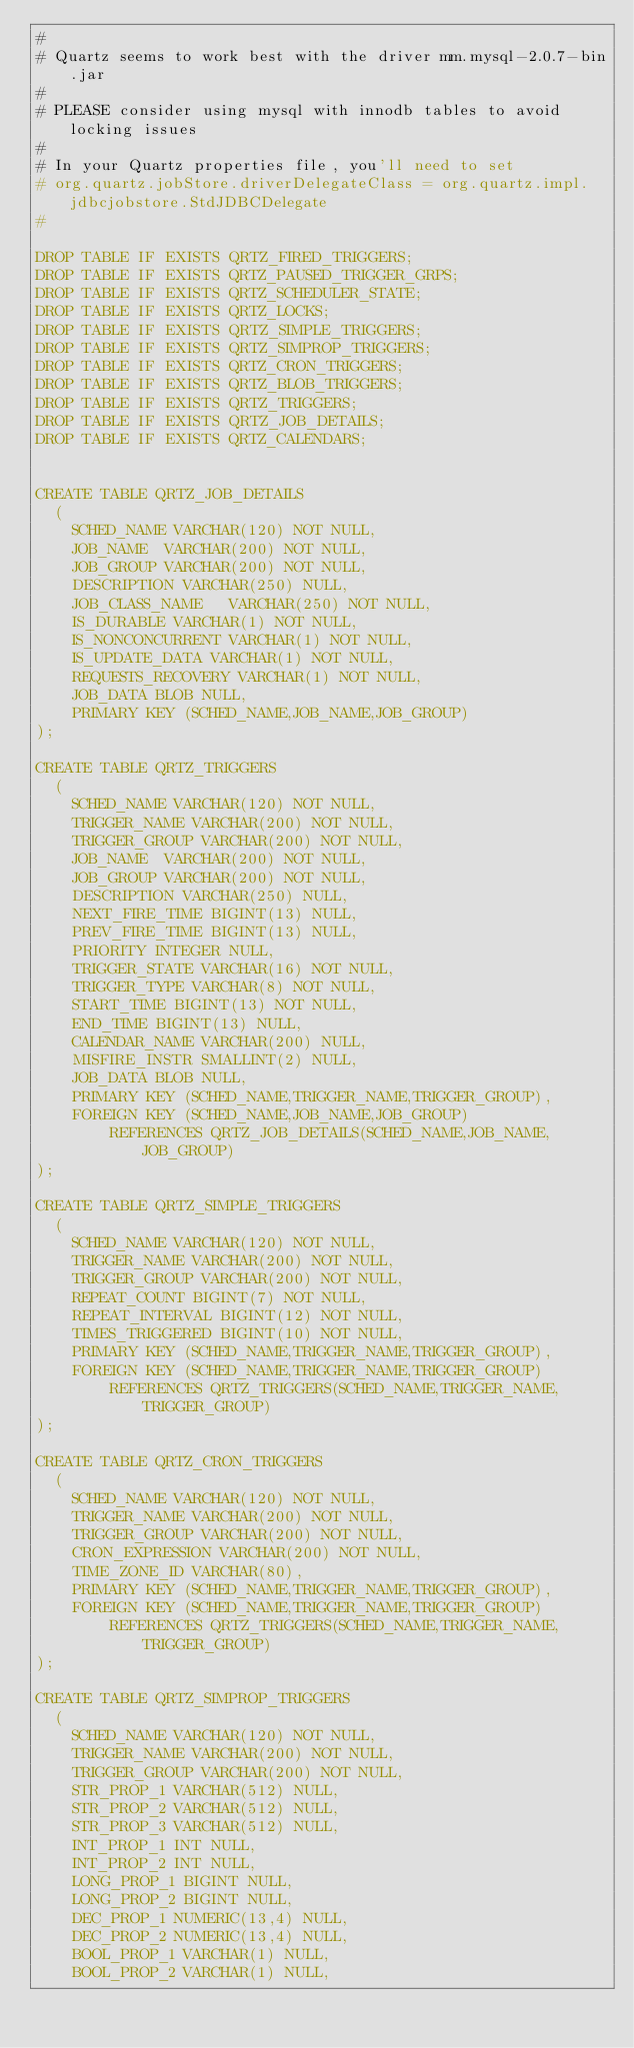<code> <loc_0><loc_0><loc_500><loc_500><_SQL_>#
# Quartz seems to work best with the driver mm.mysql-2.0.7-bin.jar
#
# PLEASE consider using mysql with innodb tables to avoid locking issues
#
# In your Quartz properties file, you'll need to set
# org.quartz.jobStore.driverDelegateClass = org.quartz.impl.jdbcjobstore.StdJDBCDelegate
#

DROP TABLE IF EXISTS QRTZ_FIRED_TRIGGERS;
DROP TABLE IF EXISTS QRTZ_PAUSED_TRIGGER_GRPS;
DROP TABLE IF EXISTS QRTZ_SCHEDULER_STATE;
DROP TABLE IF EXISTS QRTZ_LOCKS;
DROP TABLE IF EXISTS QRTZ_SIMPLE_TRIGGERS;
DROP TABLE IF EXISTS QRTZ_SIMPROP_TRIGGERS;
DROP TABLE IF EXISTS QRTZ_CRON_TRIGGERS;
DROP TABLE IF EXISTS QRTZ_BLOB_TRIGGERS;
DROP TABLE IF EXISTS QRTZ_TRIGGERS;
DROP TABLE IF EXISTS QRTZ_JOB_DETAILS;
DROP TABLE IF EXISTS QRTZ_CALENDARS;


CREATE TABLE QRTZ_JOB_DETAILS
  (
    SCHED_NAME VARCHAR(120) NOT NULL,
    JOB_NAME  VARCHAR(200) NOT NULL,
    JOB_GROUP VARCHAR(200) NOT NULL,
    DESCRIPTION VARCHAR(250) NULL,
    JOB_CLASS_NAME   VARCHAR(250) NOT NULL,
    IS_DURABLE VARCHAR(1) NOT NULL,
    IS_NONCONCURRENT VARCHAR(1) NOT NULL,
    IS_UPDATE_DATA VARCHAR(1) NOT NULL,
    REQUESTS_RECOVERY VARCHAR(1) NOT NULL,
    JOB_DATA BLOB NULL,
    PRIMARY KEY (SCHED_NAME,JOB_NAME,JOB_GROUP)
);

CREATE TABLE QRTZ_TRIGGERS
  (
    SCHED_NAME VARCHAR(120) NOT NULL,
    TRIGGER_NAME VARCHAR(200) NOT NULL,
    TRIGGER_GROUP VARCHAR(200) NOT NULL,
    JOB_NAME  VARCHAR(200) NOT NULL,
    JOB_GROUP VARCHAR(200) NOT NULL,
    DESCRIPTION VARCHAR(250) NULL,
    NEXT_FIRE_TIME BIGINT(13) NULL,
    PREV_FIRE_TIME BIGINT(13) NULL,
    PRIORITY INTEGER NULL,
    TRIGGER_STATE VARCHAR(16) NOT NULL,
    TRIGGER_TYPE VARCHAR(8) NOT NULL,
    START_TIME BIGINT(13) NOT NULL,
    END_TIME BIGINT(13) NULL,
    CALENDAR_NAME VARCHAR(200) NULL,
    MISFIRE_INSTR SMALLINT(2) NULL,
    JOB_DATA BLOB NULL,
    PRIMARY KEY (SCHED_NAME,TRIGGER_NAME,TRIGGER_GROUP),
    FOREIGN KEY (SCHED_NAME,JOB_NAME,JOB_GROUP)
        REFERENCES QRTZ_JOB_DETAILS(SCHED_NAME,JOB_NAME,JOB_GROUP)
);

CREATE TABLE QRTZ_SIMPLE_TRIGGERS
  (
    SCHED_NAME VARCHAR(120) NOT NULL,
    TRIGGER_NAME VARCHAR(200) NOT NULL,
    TRIGGER_GROUP VARCHAR(200) NOT NULL,
    REPEAT_COUNT BIGINT(7) NOT NULL,
    REPEAT_INTERVAL BIGINT(12) NOT NULL,
    TIMES_TRIGGERED BIGINT(10) NOT NULL,
    PRIMARY KEY (SCHED_NAME,TRIGGER_NAME,TRIGGER_GROUP),
    FOREIGN KEY (SCHED_NAME,TRIGGER_NAME,TRIGGER_GROUP)
        REFERENCES QRTZ_TRIGGERS(SCHED_NAME,TRIGGER_NAME,TRIGGER_GROUP)
);

CREATE TABLE QRTZ_CRON_TRIGGERS
  (
    SCHED_NAME VARCHAR(120) NOT NULL,
    TRIGGER_NAME VARCHAR(200) NOT NULL,
    TRIGGER_GROUP VARCHAR(200) NOT NULL,
    CRON_EXPRESSION VARCHAR(200) NOT NULL,
    TIME_ZONE_ID VARCHAR(80),
    PRIMARY KEY (SCHED_NAME,TRIGGER_NAME,TRIGGER_GROUP),
    FOREIGN KEY (SCHED_NAME,TRIGGER_NAME,TRIGGER_GROUP)
        REFERENCES QRTZ_TRIGGERS(SCHED_NAME,TRIGGER_NAME,TRIGGER_GROUP)
);

CREATE TABLE QRTZ_SIMPROP_TRIGGERS
  (
    SCHED_NAME VARCHAR(120) NOT NULL,
    TRIGGER_NAME VARCHAR(200) NOT NULL,
    TRIGGER_GROUP VARCHAR(200) NOT NULL,
    STR_PROP_1 VARCHAR(512) NULL,
    STR_PROP_2 VARCHAR(512) NULL,
    STR_PROP_3 VARCHAR(512) NULL,
    INT_PROP_1 INT NULL,
    INT_PROP_2 INT NULL,
    LONG_PROP_1 BIGINT NULL,
    LONG_PROP_2 BIGINT NULL,
    DEC_PROP_1 NUMERIC(13,4) NULL,
    DEC_PROP_2 NUMERIC(13,4) NULL,
    BOOL_PROP_1 VARCHAR(1) NULL,
    BOOL_PROP_2 VARCHAR(1) NULL,</code> 